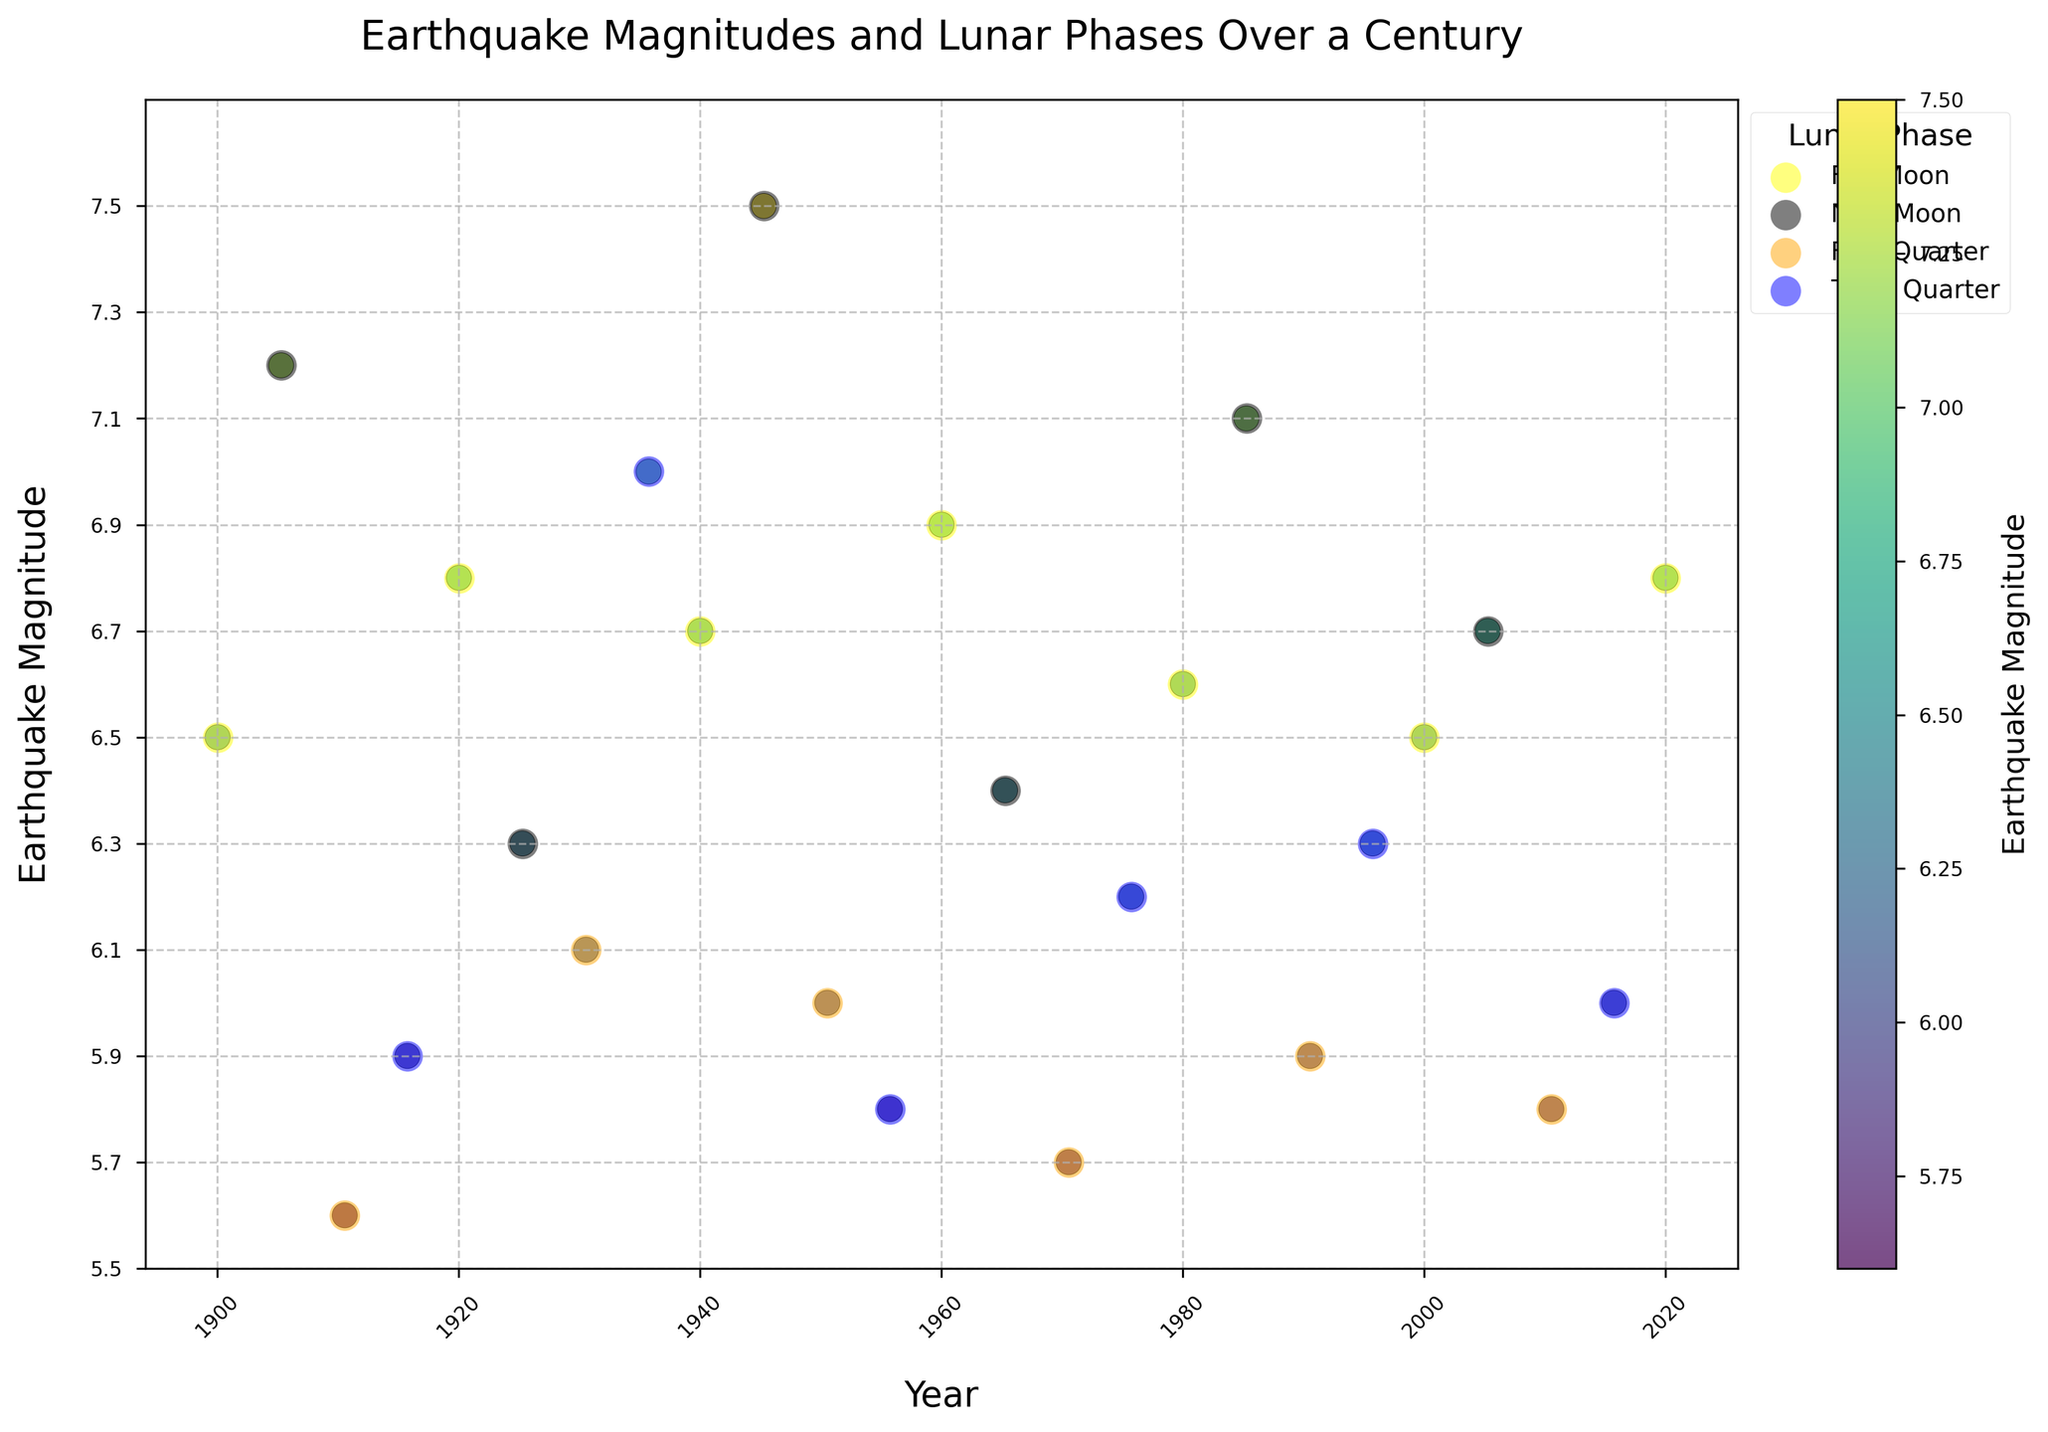What is the title of the plot? The title is located at the top of the figure and gives a summary of what the plot represents. In this case, it reads: "Earthquake Magnitudes and Lunar Phases Over a Century."
Answer: Earthquake Magnitudes and Lunar Phases Over a Century How many earthquake events are plotted over the century? Each event is represented by a colored scatter point on the plot. By counting these points, you can determine the number of events. There are 26 such points on the plot.
Answer: 26 What is the highest earthquake magnitude recorded on the plot, and in which lunar phase did it occur? Find the highest point on the y-axis, which represents the earthquake magnitude, and note the color of the scatter point which indicates the lunar phase. The highest magnitude recorded is 7.5, which occurred during a New Moon.
Answer: 7.5, New Moon How does the frequency of earthquakes vary with different lunar phases? Look at the scatter points' colors to separate events under different lunar phases. Count the points for each phase (Full Moon, New Moon, First Quarter, Third Quarter). Full Moon: 6, New Moon: 6, First Quarter: 6, Third Quarter: 7.
Answer: Full Moon: 6, New Moon: 6, First Quarter: 6, Third Quarter: 7 Which period shows the densest clustering of high-magnitude earthquakes? Examine the dense regions on the y-axis where magnitudes are high. The densest clustering of high-magnitude earthquakes occurs around the years 1940-1950.
Answer: 1940-1950 What's the average magnitude of earthquakes occurring during the First Quarter? Isolate the magnitudes for the First Quarter phase (5.6, 6.1, 6.0, 5.7, 5.9, 5.8). Sum these values and divide by their count (6). (5.6 + 6.1 + 6.0 + 5.7 + 5.9 + 5.8) / 6 ≈ 5.85.
Answer: 5.85 Which year observed the lowest earthquake magnitude, and what was the lunar phase at that time? Find the lowest point on the y-axis representing earthquake magnitude and check its corresponding lunar phase color. The lowest magnitude of 5.6 was observed in 1910 during the First Quarter.
Answer: 1910, First Quarter Is there a noticeable correlation between the colors of the scatter points and the magnitude of the earthquakes? Observe if any specific color (representing lunar phases) clusters around certain magnitude ranges. There appears to be no strong correlation between lunar phases and the magnitude of the earthquakes.
Answer: No Which lunar phase has the most spread in earthquake magnitudes, and what is the range? Identify the range of magnitudes for each lunar phase. The New Moon phase has the most spread, ranging from 6.3 to 7.5, giving a range of 1.2.
Answer: New Moon, 1.2 Between 2000 and 2020, did higher or lower magnitude earthquakes become more frequent, and during which lunar phases? Focus on the scatter points between the years 2000 and 2020. Compare the number of high (above median) versus low (below median) magnitudes. Earthquakes around 6.7-6.8 were frequent, particularly during Full Moon and New Moon phases.
Answer: 2000-2020, Full Moon, New Moon 